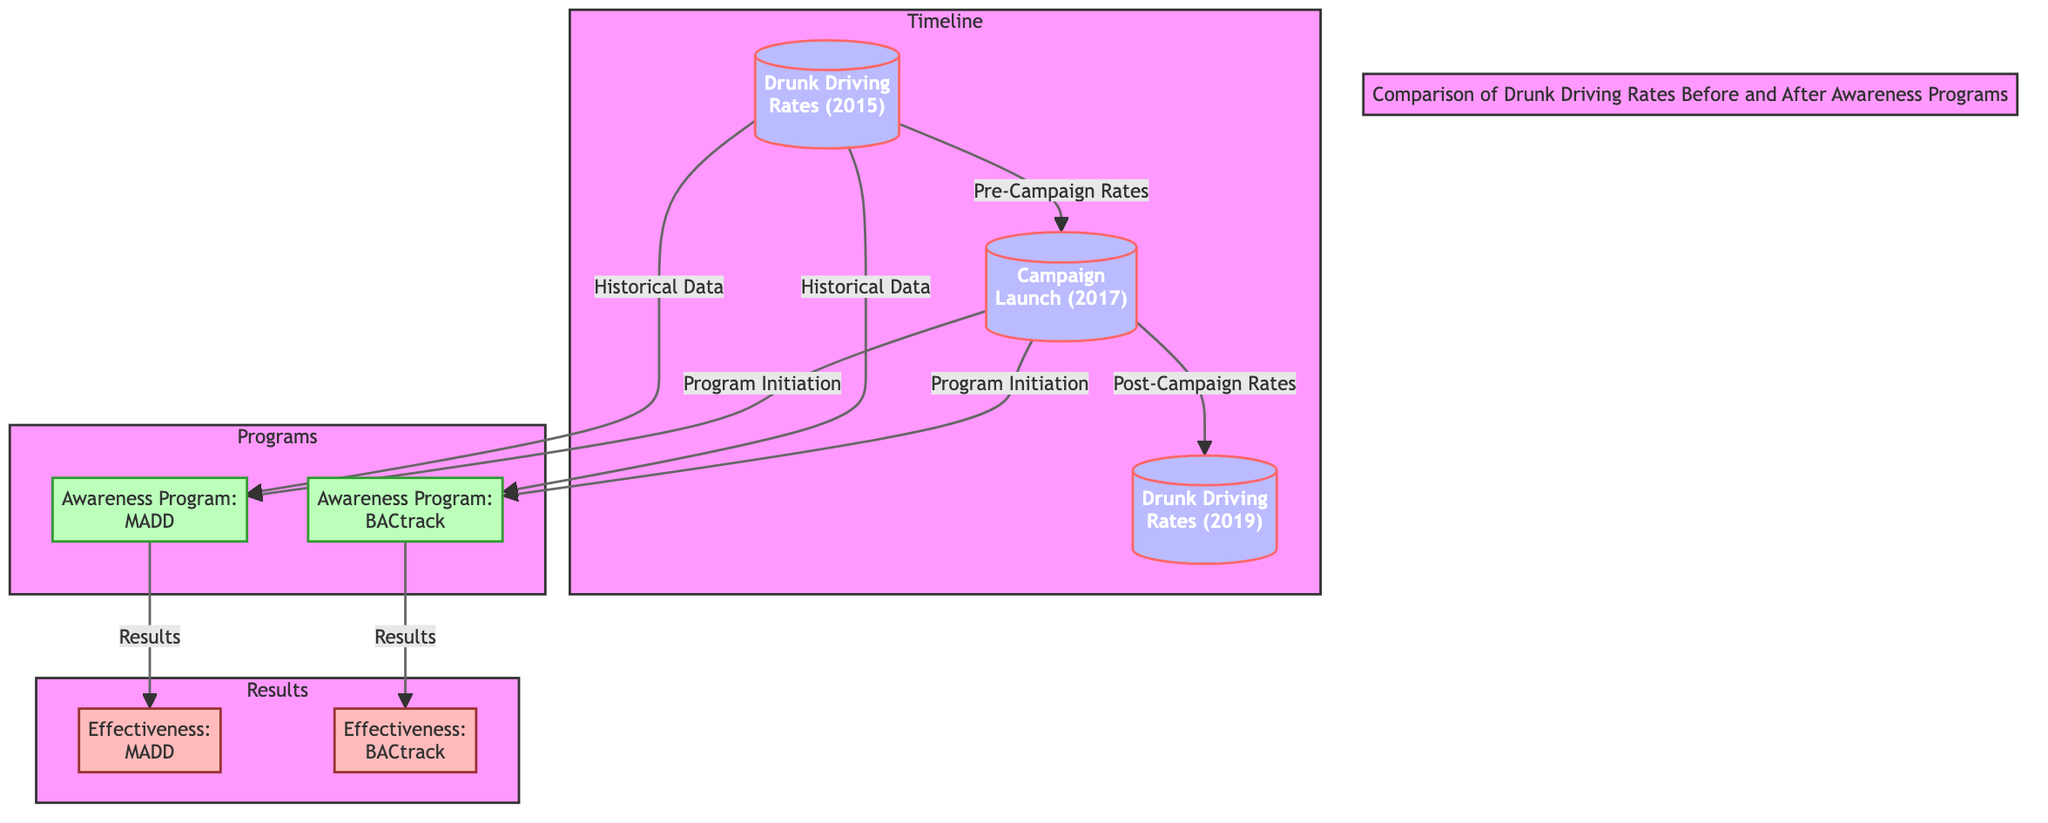What year was the campaign launched? The diagram shows a timeline with a specific node indicating the "Campaign Launch (2017)". This directly answers the question regarding when the campaign began.
Answer: 2017 What is the first node in the timeline? The first node in the timeline is labeled "Drunk Driving Rates (2015)". Since it is the starting point, it satisfies the inquiry about the initial information in the timeline.
Answer: Drunk Driving Rates (2015) How many awareness programs are listed in the diagram? The diagram contains two distinct nodes under the "Programs" subgraph: "Awareness Program: MADD" and "Awareness Program: BACtrack". Therefore, to answer how many awareness programs there are, I simply count these nodes.
Answer: 2 What does the effectiveness of the MADD program relate to? Following the flow from the "Awareness Program: MADD" node, it leads directly to the "Effectiveness: MADD" node. This signifies that the effectiveness of the MADD program is the outcome of the campaign related to it.
Answer: Effectiveness: MADD What are the drunk driving rates compared between? The points of comparison in the diagram are at two specified times: "Drunk Driving Rates (2015)" and "Drunk Driving Rates (2019)", providing clear markers for the comparison pre and post the awareness campaigns.
Answer: 2015 and 2019 What is the connection between Historical Data and the awareness programs? The "Historical Data" points in the diagram link to both awareness programs before their respective campaign initiation in 2017. Thus, the connection indicates that historical data informs these programs.
Answer: Historical Data to Awareness Programs Which program is associated with the node labeled "Effectiveness: BACtrack"? The flow from "Awareness Program: BACtrack" node directly leads to the "Effectiveness: BACtrack" node, establishing that the effectiveness discussed is specifically tied to the BACtrack program's initiative.
Answer: Effectiveness: BACtrack What structure does this diagram follow to display information? The arrangement of the diagram consists of three subgraphs: Timeline, Programs, and Results. This organization serves to categorize the different aspects of drunk driving rates, awareness programs, and their outcomes clearly.
Answer: Subgraphs: Timeline, Programs, Results 